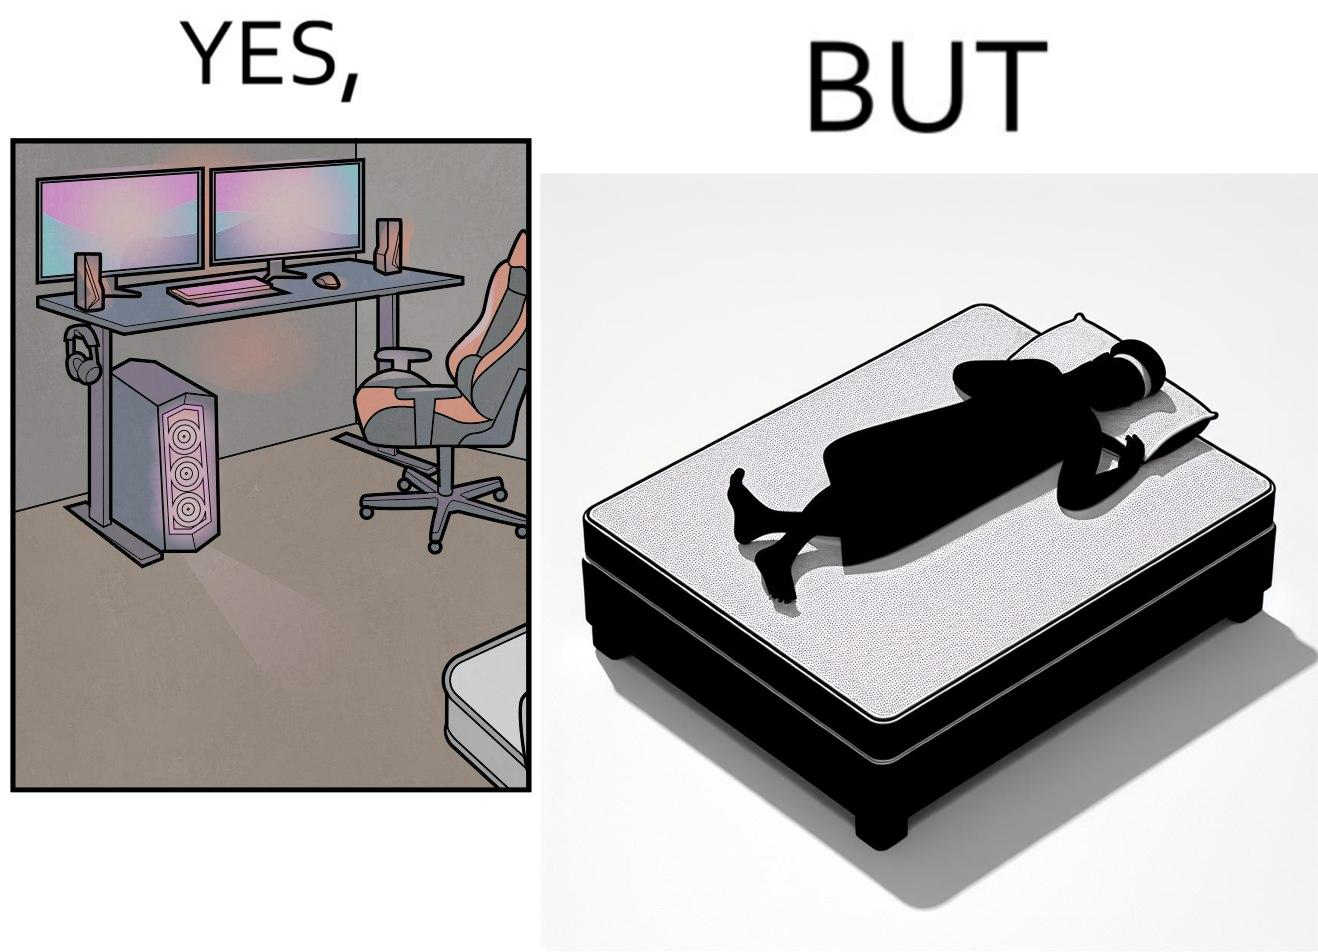Is this image satirical or non-satirical? Yes, this image is satirical. 